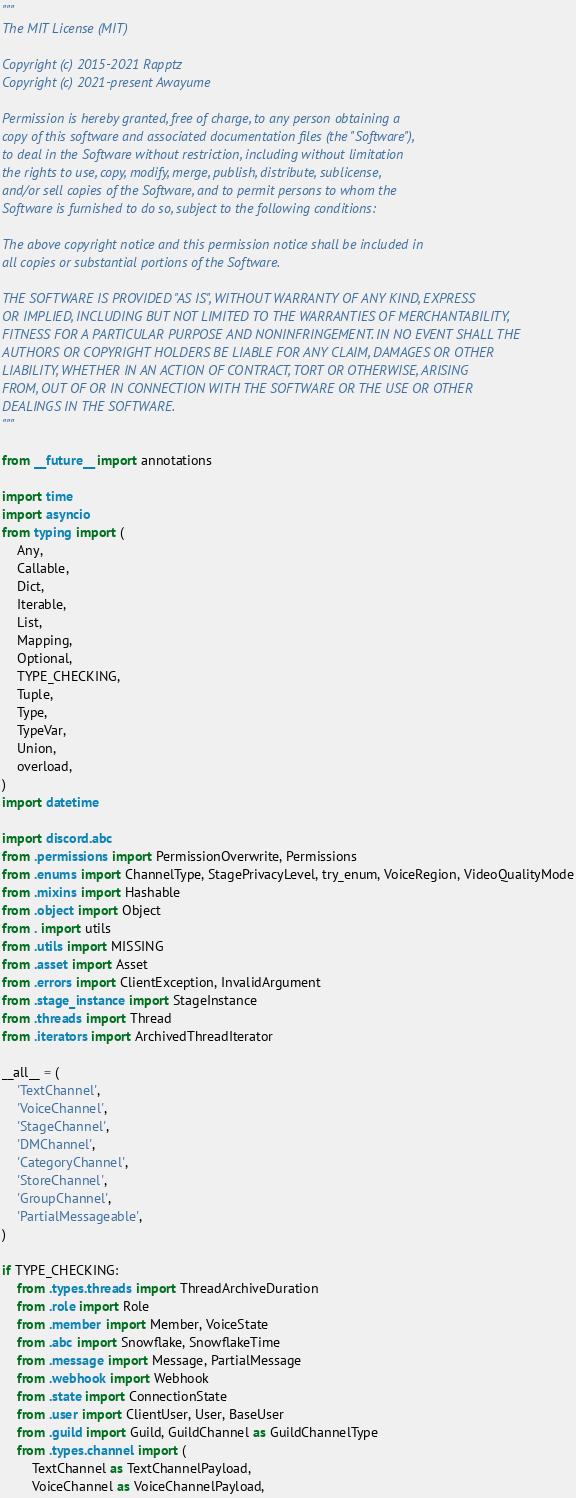<code> <loc_0><loc_0><loc_500><loc_500><_Python_>"""
The MIT License (MIT)

Copyright (c) 2015-2021 Rapptz
Copyright (c) 2021-present Awayume

Permission is hereby granted, free of charge, to any person obtaining a
copy of this software and associated documentation files (the "Software"),
to deal in the Software without restriction, including without limitation
the rights to use, copy, modify, merge, publish, distribute, sublicense,
and/or sell copies of the Software, and to permit persons to whom the
Software is furnished to do so, subject to the following conditions:

The above copyright notice and this permission notice shall be included in
all copies or substantial portions of the Software.

THE SOFTWARE IS PROVIDED "AS IS", WITHOUT WARRANTY OF ANY KIND, EXPRESS
OR IMPLIED, INCLUDING BUT NOT LIMITED TO THE WARRANTIES OF MERCHANTABILITY,
FITNESS FOR A PARTICULAR PURPOSE AND NONINFRINGEMENT. IN NO EVENT SHALL THE
AUTHORS OR COPYRIGHT HOLDERS BE LIABLE FOR ANY CLAIM, DAMAGES OR OTHER
LIABILITY, WHETHER IN AN ACTION OF CONTRACT, TORT OR OTHERWISE, ARISING
FROM, OUT OF OR IN CONNECTION WITH THE SOFTWARE OR THE USE OR OTHER
DEALINGS IN THE SOFTWARE.
"""

from __future__ import annotations

import time
import asyncio
from typing import (
    Any,
    Callable,
    Dict,
    Iterable,
    List,
    Mapping,
    Optional,
    TYPE_CHECKING,
    Tuple,
    Type,
    TypeVar,
    Union,
    overload,
)
import datetime

import discord.abc
from .permissions import PermissionOverwrite, Permissions
from .enums import ChannelType, StagePrivacyLevel, try_enum, VoiceRegion, VideoQualityMode
from .mixins import Hashable
from .object import Object
from . import utils
from .utils import MISSING
from .asset import Asset
from .errors import ClientException, InvalidArgument
from .stage_instance import StageInstance
from .threads import Thread
from .iterators import ArchivedThreadIterator

__all__ = (
    'TextChannel',
    'VoiceChannel',
    'StageChannel',
    'DMChannel',
    'CategoryChannel',
    'StoreChannel',
    'GroupChannel',
    'PartialMessageable',
)

if TYPE_CHECKING:
    from .types.threads import ThreadArchiveDuration
    from .role import Role
    from .member import Member, VoiceState
    from .abc import Snowflake, SnowflakeTime
    from .message import Message, PartialMessage
    from .webhook import Webhook
    from .state import ConnectionState
    from .user import ClientUser, User, BaseUser
    from .guild import Guild, GuildChannel as GuildChannelType
    from .types.channel import (
        TextChannel as TextChannelPayload,
        VoiceChannel as VoiceChannelPayload,</code> 